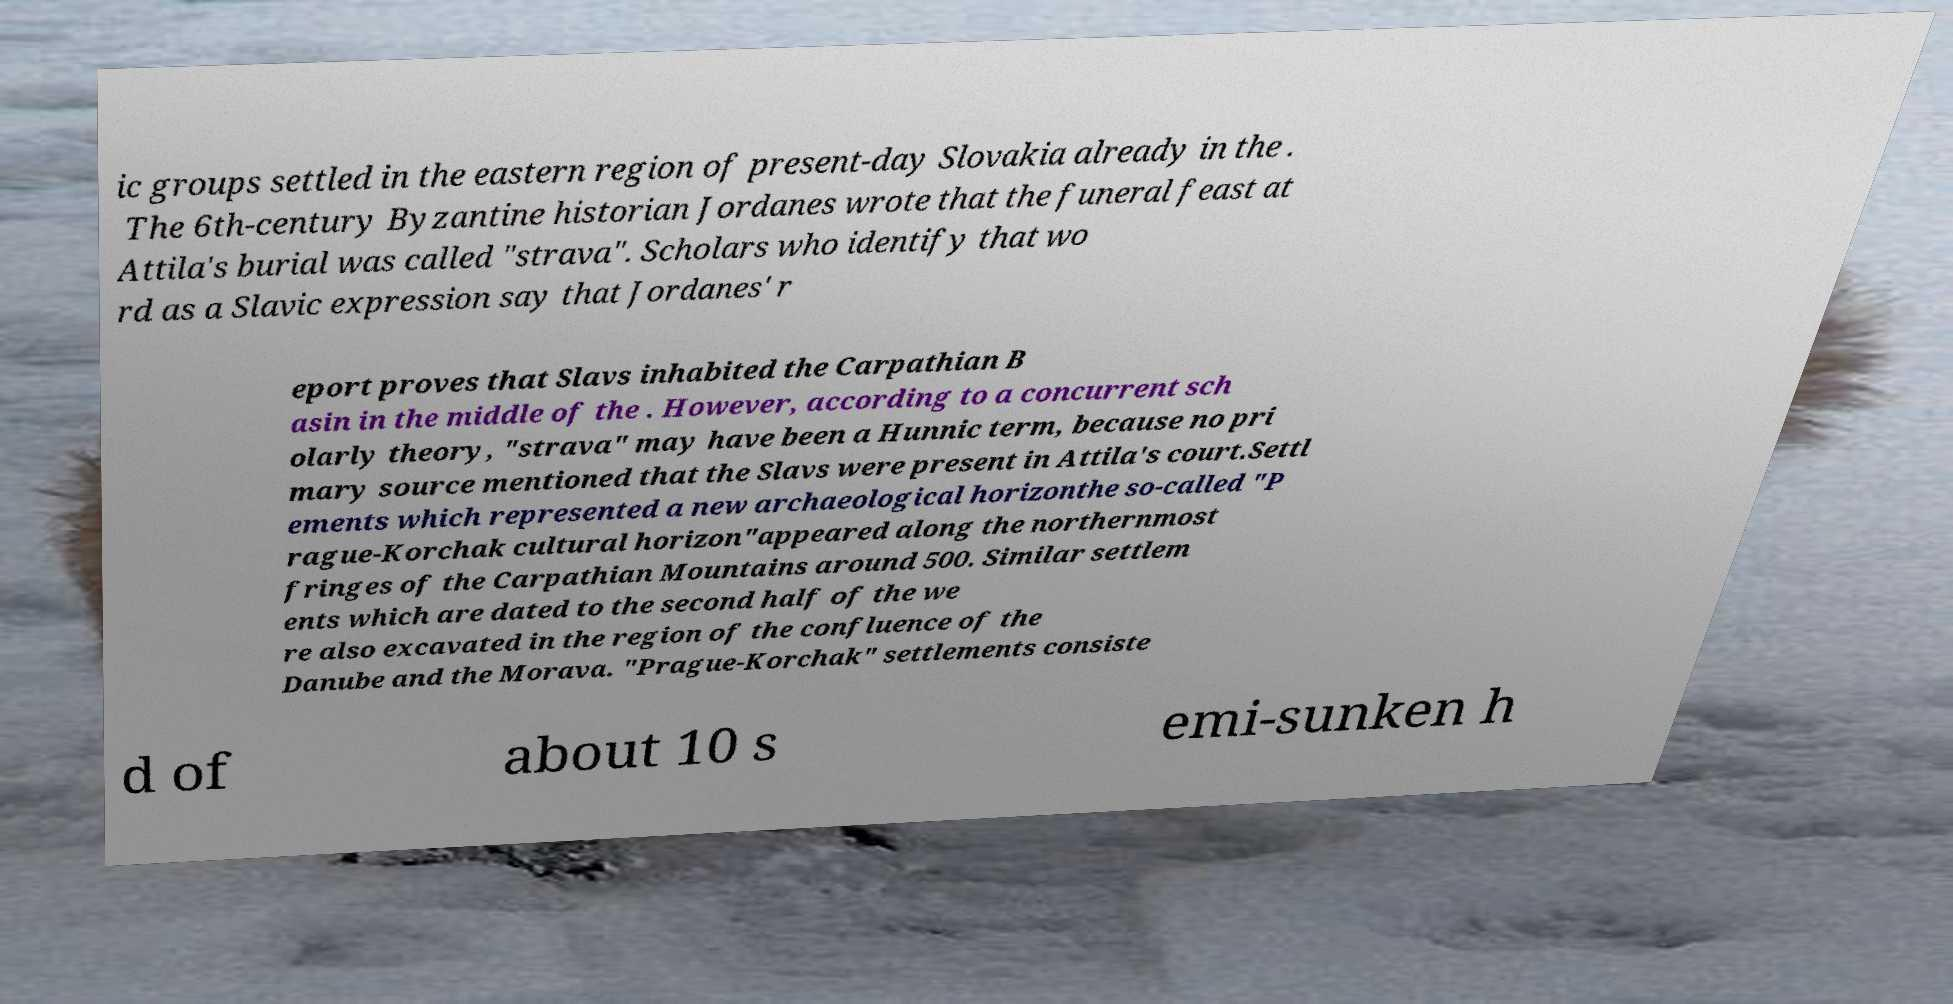There's text embedded in this image that I need extracted. Can you transcribe it verbatim? ic groups settled in the eastern region of present-day Slovakia already in the . The 6th-century Byzantine historian Jordanes wrote that the funeral feast at Attila's burial was called "strava". Scholars who identify that wo rd as a Slavic expression say that Jordanes' r eport proves that Slavs inhabited the Carpathian B asin in the middle of the . However, according to a concurrent sch olarly theory, "strava" may have been a Hunnic term, because no pri mary source mentioned that the Slavs were present in Attila's court.Settl ements which represented a new archaeological horizonthe so-called "P rague-Korchak cultural horizon"appeared along the northernmost fringes of the Carpathian Mountains around 500. Similar settlem ents which are dated to the second half of the we re also excavated in the region of the confluence of the Danube and the Morava. "Prague-Korchak" settlements consiste d of about 10 s emi-sunken h 